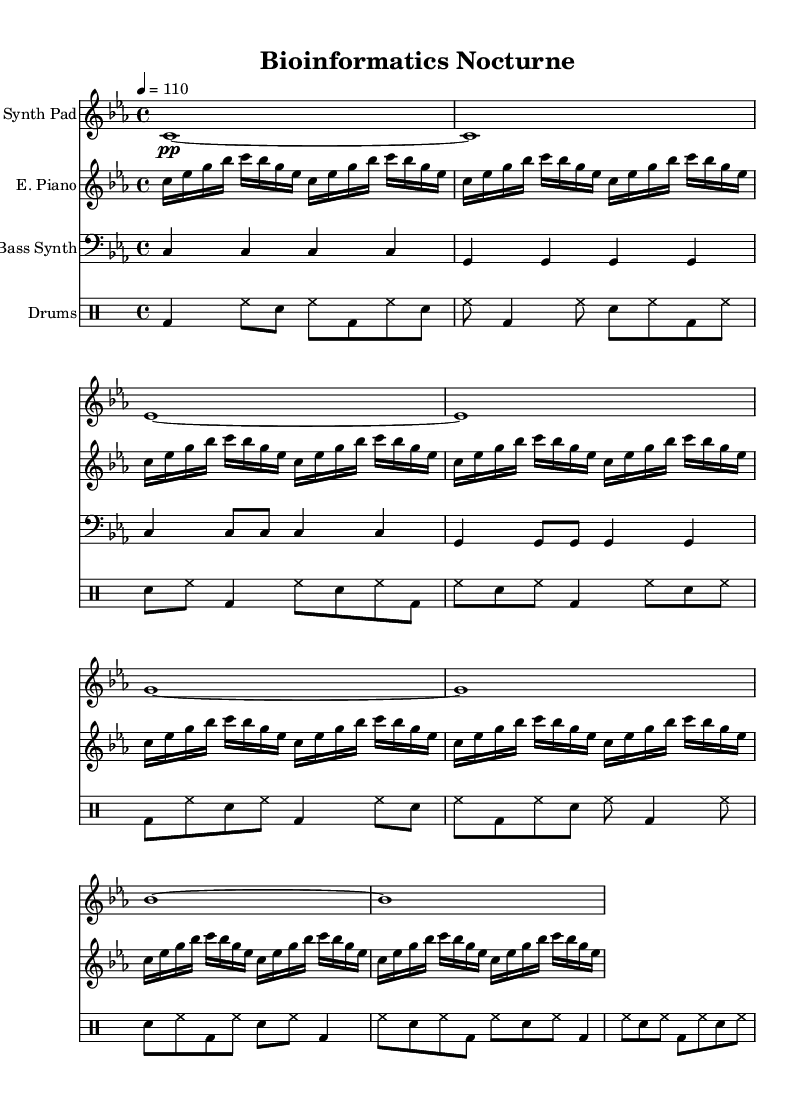What is the key signature of this music? The key signature is indicated at the beginning of the staff. Here, it shows three flats, which designates C minor.
Answer: C minor What is the time signature of this music? The time signature is located at the beginning of the score right after the key signature. It shows 4/4, meaning four beats per measure and a quarter note gets one beat.
Answer: 4/4 What is the tempo marking for this music? The tempo marking is found at the top of the score. It indicates a tempo of 110 beats per minute, guiding the pace for performing the piece.
Answer: 110 Which instrument plays the bass line? The instrument that plays the bass line is located in the bass staff. It is labeled as "Bass Synth," indicating it provides the low-frequency support typical in house music.
Answer: Bass Synth How many measures are in the synthesized pad section? To determine this, we can count the measures in the Synth Pad staff from the beginning to the end of the section. There are a total of 8 measures in this part.
Answer: 8 What rhythmic figure is primarily used in the drum section? The drum section is analyzed by observing the pattern of notes. The quarter note bass drum, paired with alternating snare and hi-hat notes, creates a driving four-on-the-floor rhythm typical of house music.
Answer: Four-on-the-floor What is the primary texture of this piece? The texture is based on the layering of multiple synth lines, including a pad, electric piano, and bass, all working together harmonically, as is characteristic of ambient house music, resulting in a rich sound.
Answer: Layered 